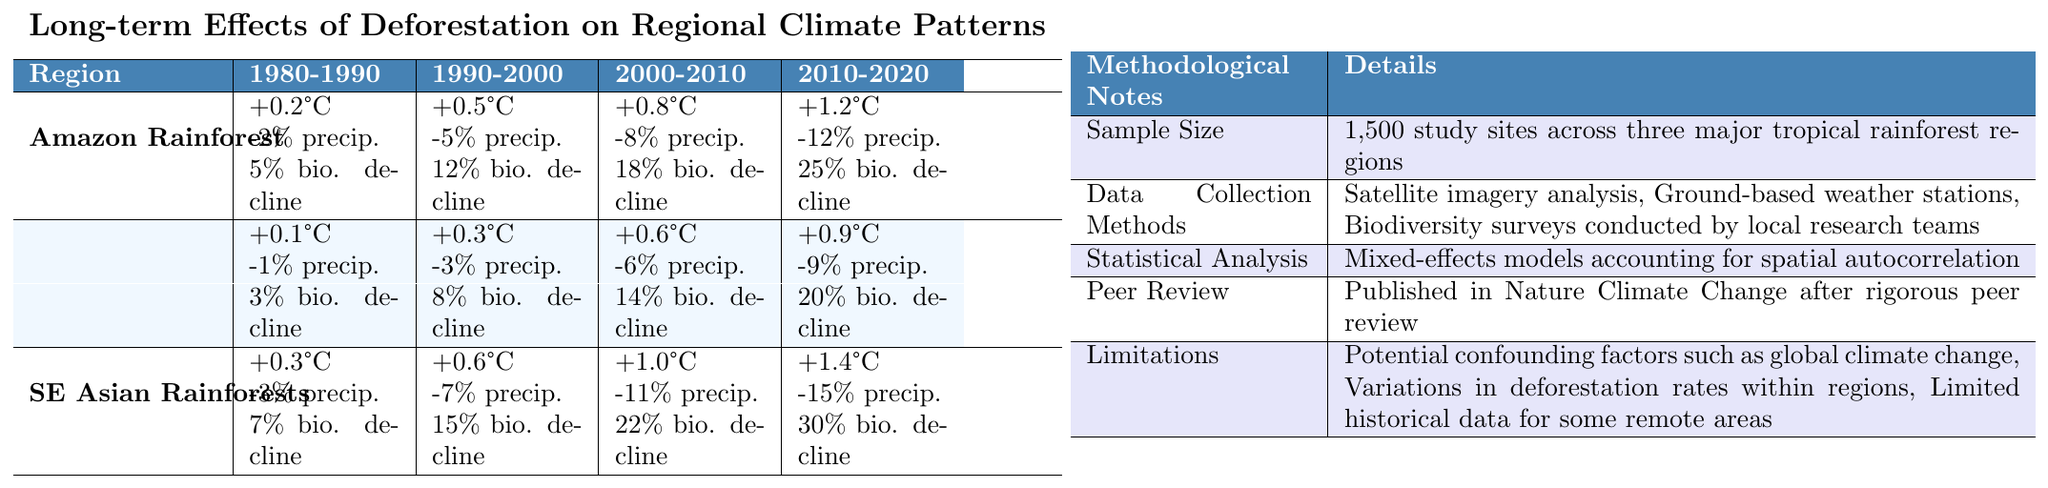What were the temperature changes in the Amazon Rainforest from 2000 to 2010? The table shows that the temperature change in the Amazon Rainforest from 2000 to 2010 was +0.8°C.
Answer: +0.8°C What was the percentage decline in biodiversity in Southeast Asian Rainforests from 1980 to 1990? The table indicates a 7% decline in biodiversity in Southeast Asian Rainforests from 1980 to 1990.
Answer: 7% Did the Congo Basin experience a greater decline in annual precipitation from 2010 to 2020 compared to the Amazon Rainforest? The Congo Basin experienced a -9% decline in annual precipitation from 2010 to 2020, whereas the Amazon Rainforest experienced a -12% decline in the same period. Therefore, the Amazon Rainforest had a greater decline.
Answer: No What is the total decline in species richness for the Amazon Rainforest from 1980 to 2020? The percentage declines in species richness for the Amazon Rainforest are: 5% (1980-1990), 12% (1990-2000), 18% (2000-2010), and 25% (2010-2020). Adding these together gives us 5 + 12 + 18 + 25 = 60%, indicating a total decline of 60% from 1980 to 2020.
Answer: 60% Which region had the highest temperature increase from 1980 to 2020? In the table, the temperature increase from 1980 to 2020 is as follows: Amazon Rainforest: +1.2°C, Congo Basin: +0.9°C, Southeast Asian Rainforests: +1.4°C. The Southeast Asian Rainforests had the highest increase of +1.4°C.
Answer: Southeast Asian Rainforests What was the average annual precipitation decline in the Congo Basin over the decades studied? The precipitation declines for the Congo Basin were: -1% (1980-1990), -3% (1990-2000), -6% (2000-2010), and -9% (2010-2020). Adding these gives -1 + -3 + -6 + -9 = -19%. There are 4 periods, so the average decline is -19/4 = -4.75%.
Answer: -4.75% Was the sample size for the study larger than 2,000 study sites? The methodological notes state that the sample size was 1,500 study sites across the three major rainforest regions, confirming it is less than 2,000.
Answer: No What trend can be observed in the decline of species richness in the Amazon Rainforest over the decades studied? The species richness decline for the Amazon Rainforest shows an increasing trend: 5% (1980-1990), 12% (1990-2000), 18% (2000-2010), and 25% (2010-2020). This indicates a consistent increase in the percentage decline over the decades.
Answer: Increasing trend 